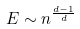Convert formula to latex. <formula><loc_0><loc_0><loc_500><loc_500>E \sim n ^ { \frac { d - 1 } { d } }</formula> 